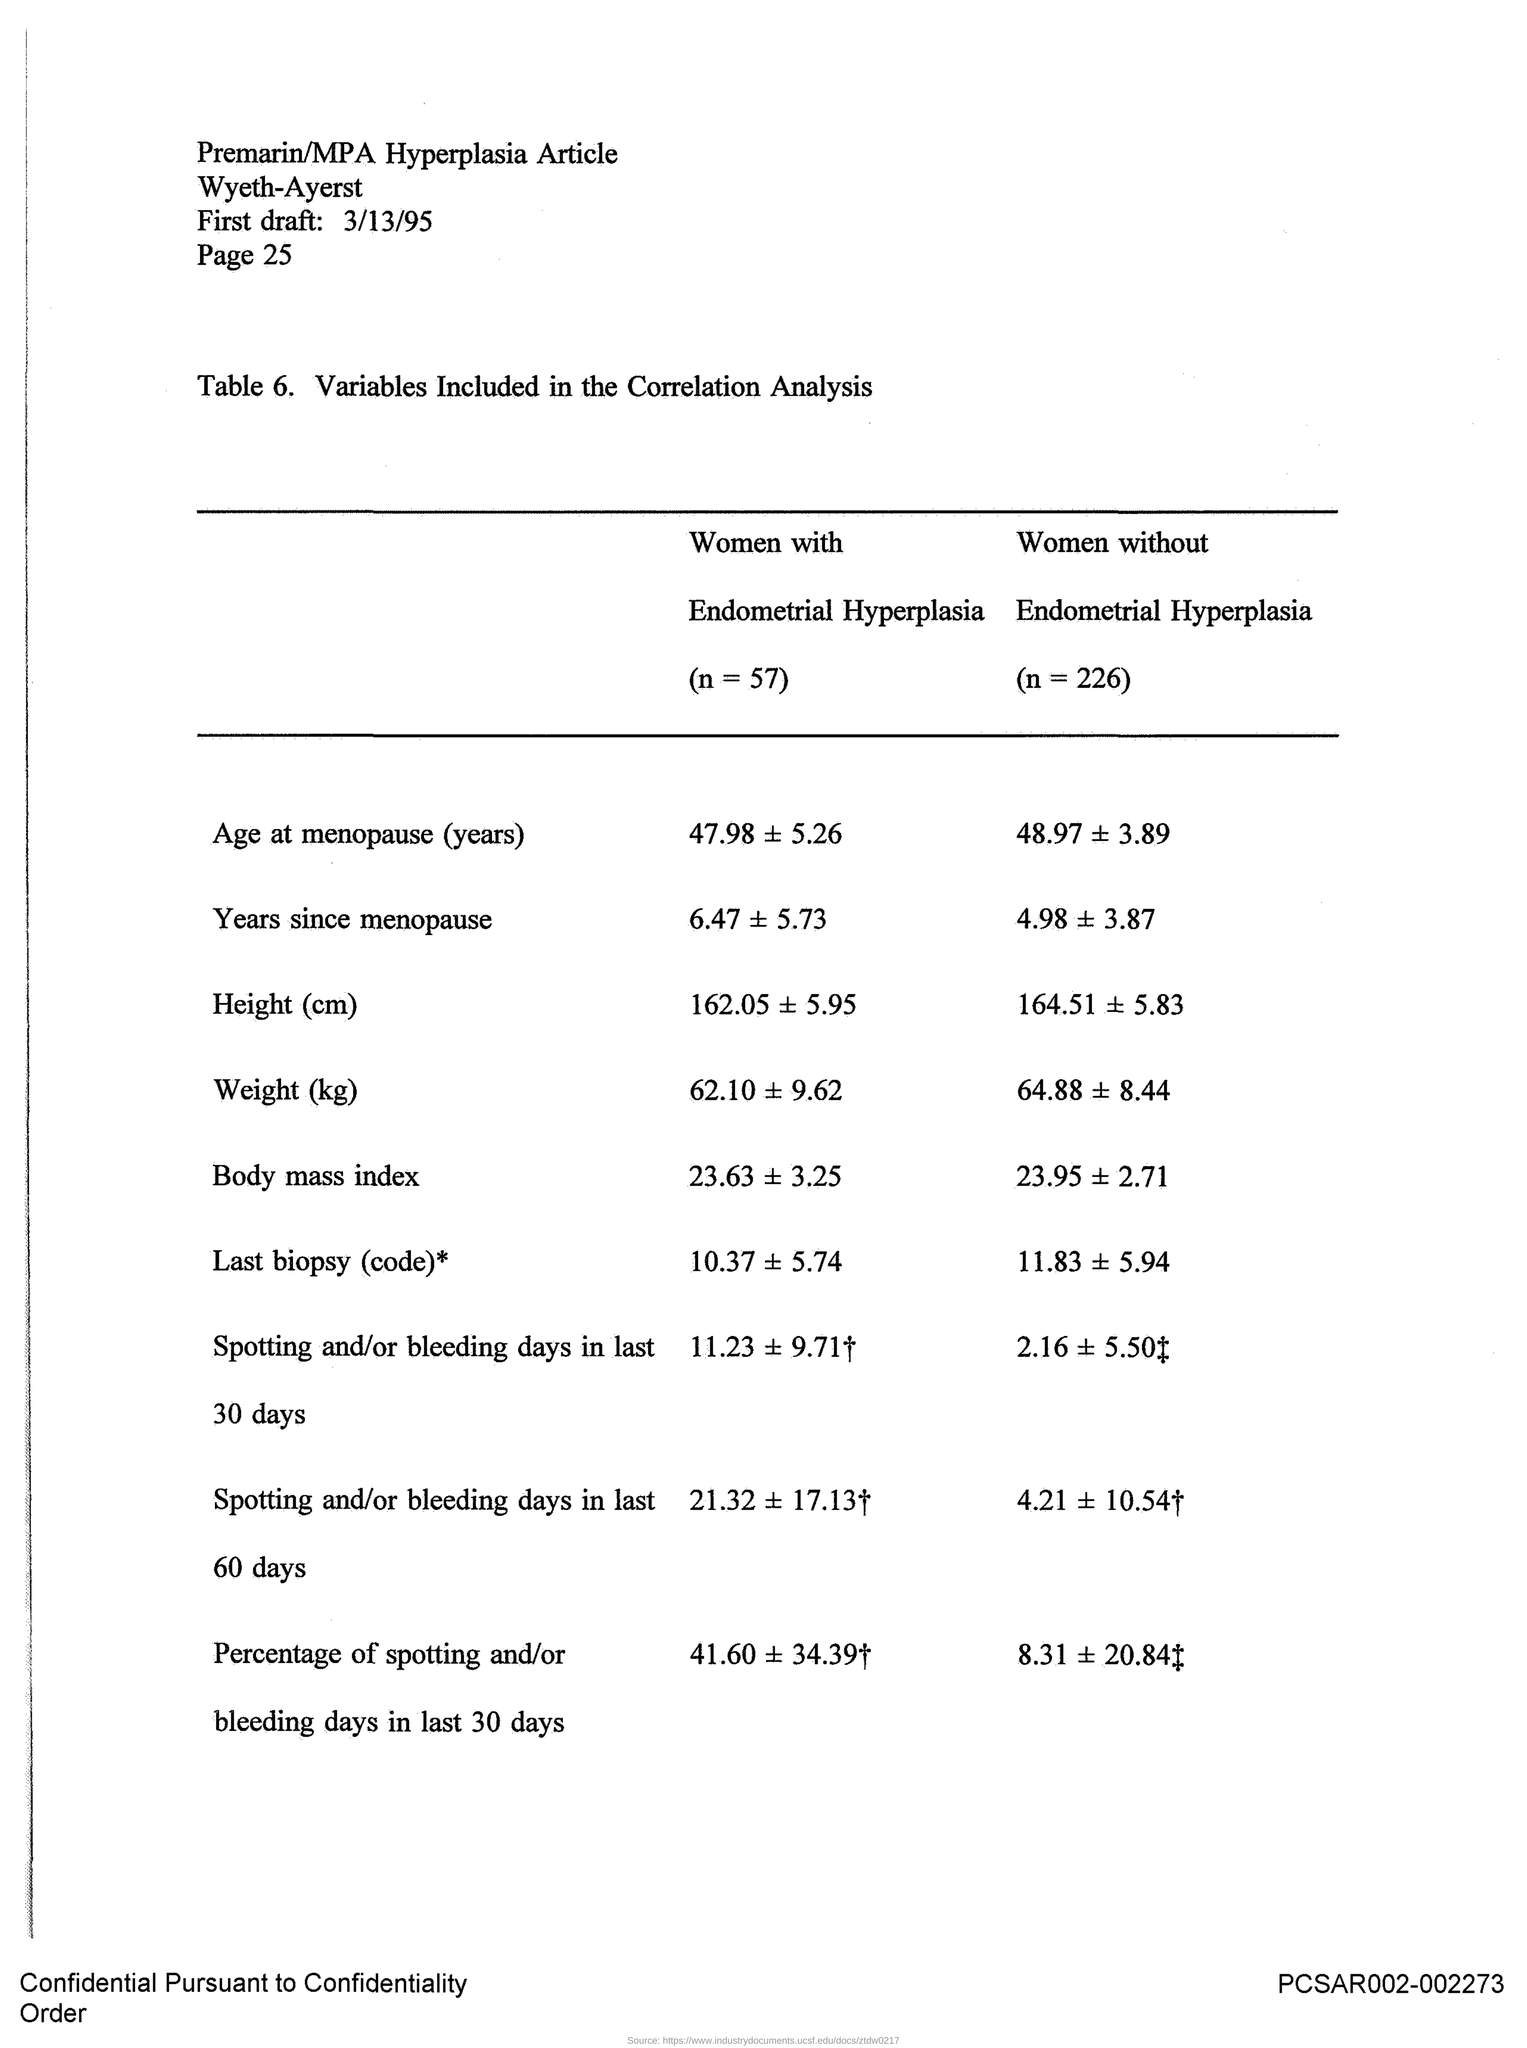Indicate a few pertinent items in this graphic. The date mentioned in the given draft is March 13, 1995. 